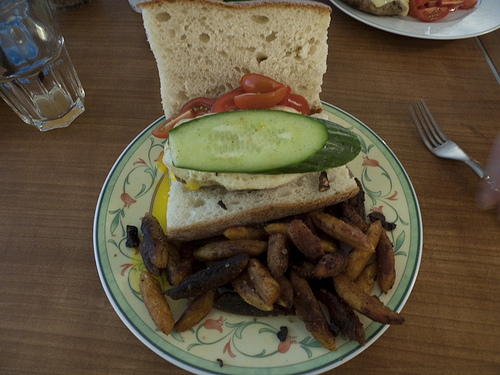<image>
Is the tomatoes on the plate? No. The tomatoes is not positioned on the plate. They may be near each other, but the tomatoes is not supported by or resting on top of the plate. 